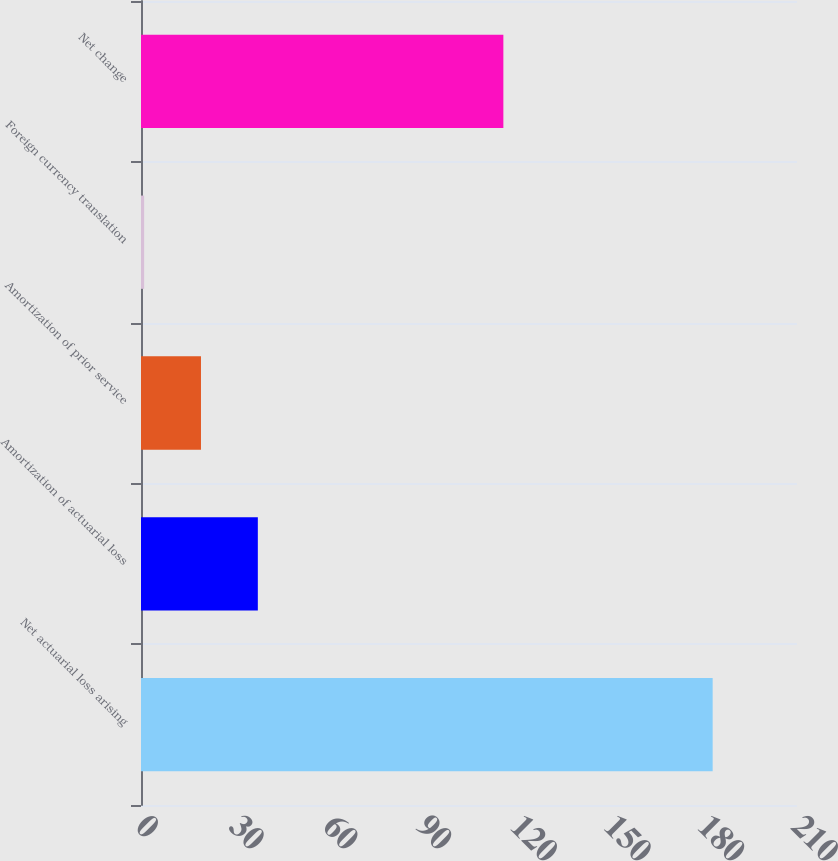Convert chart to OTSL. <chart><loc_0><loc_0><loc_500><loc_500><bar_chart><fcel>Net actuarial loss arising<fcel>Amortization of actuarial loss<fcel>Amortization of prior service<fcel>Foreign currency translation<fcel>Net change<nl><fcel>183<fcel>37.4<fcel>19.2<fcel>1<fcel>116<nl></chart> 